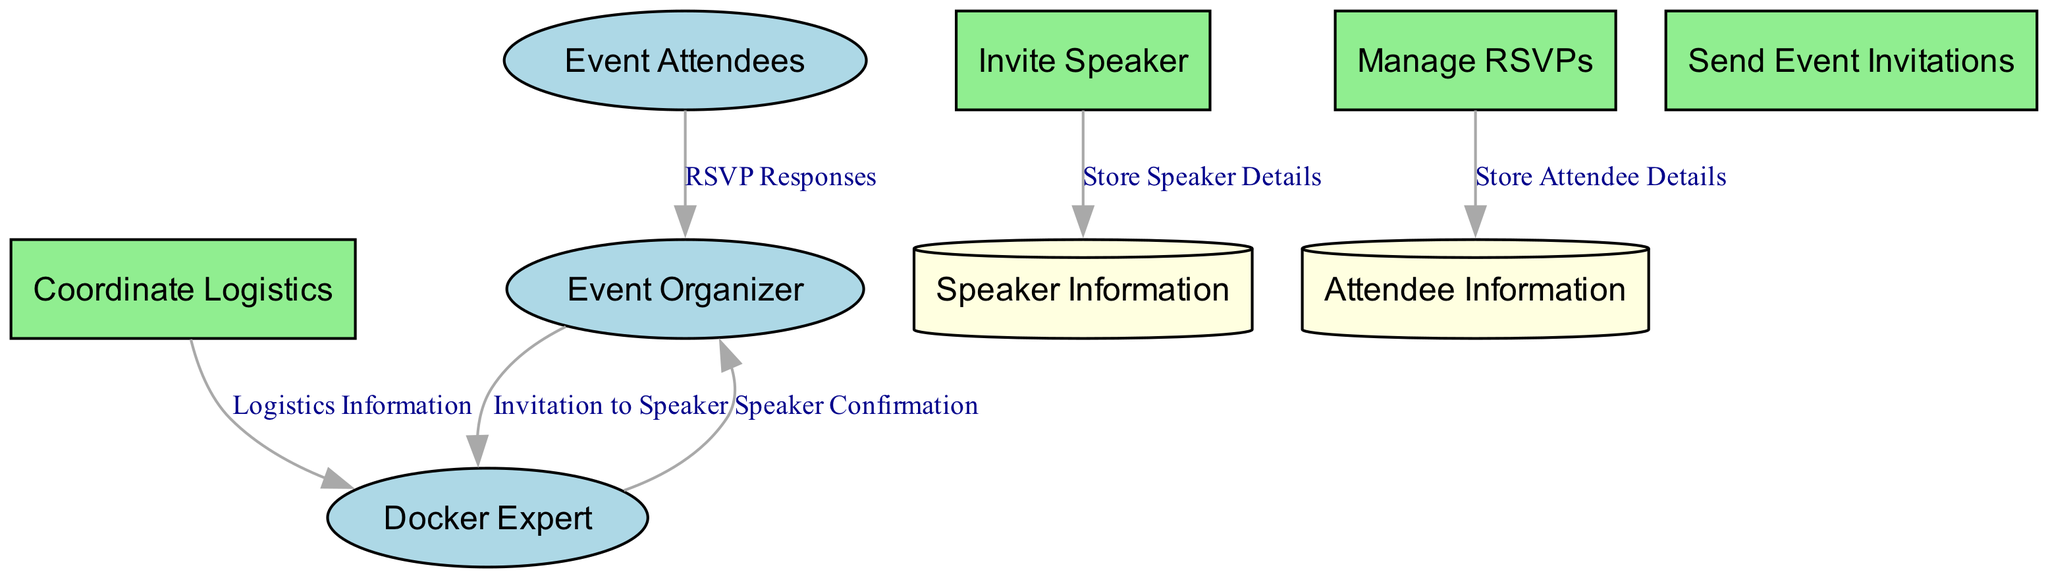What is the name of the external entity responsible for event organization? The external entity responsible for event organization is labeled as "Event Organizer" in the diagram, representing the person or team managing logistics.
Answer: Event Organizer How many processes are shown in the diagram? The diagram contains four processes: Invite Speaker, Manage RSVPs, Coordinate Logistics, and Send Event Invitations, which are identified by rectangle nodes.
Answer: 4 Who sends the invitation to the Docker expert? The data flow named "Invitation to Speaker" shows that the Event Organizer sends the invitation to the Docker expert, as indicated by the flow direction from the external entity to the process.
Answer: Event Organizer What is the purpose of the "Manage RSVPs" process? The process "Manage RSVPs" is designated for collecting and managing RSVPs from attendees, as described in the diagram.
Answer: Collecting and managing RSVPs Which data store is updated when attendees respond? The data store labeled "Attendee Information" is updated with details and RSVP status when attendees respond, as indicated by the data flow "Store Attendee Details."
Answer: Attendee Information What type of node is the "Speaker Information" categorized as? The "Speaker Information" node is categorized as a data store in the diagram, shown as a cylinder shape representing information storage.
Answer: Data store What flow indicates that the Docker expert's details are stored? The data flow named "Store Speaker Details" indicates that the Docker expert's details are stored in the Speaker Information database after the invitation process is completed.
Answer: Store Speaker Details Who receives the confirmation or rejection from the Docker expert? The confirmation or rejection from the Docker expert is sent to the Event Organizer, as shown by the data flow labeled "Speaker Confirmation" from the Docker expert to the Event Organizer.
Answer: Event Organizer What two entities are involved in the logistics information flow? The logistics information flow involves the Event Organizer and the Docker Expert, where the Event Organizer shares logistics details with the Docker Expert.
Answer: Event Organizer, Docker Expert 